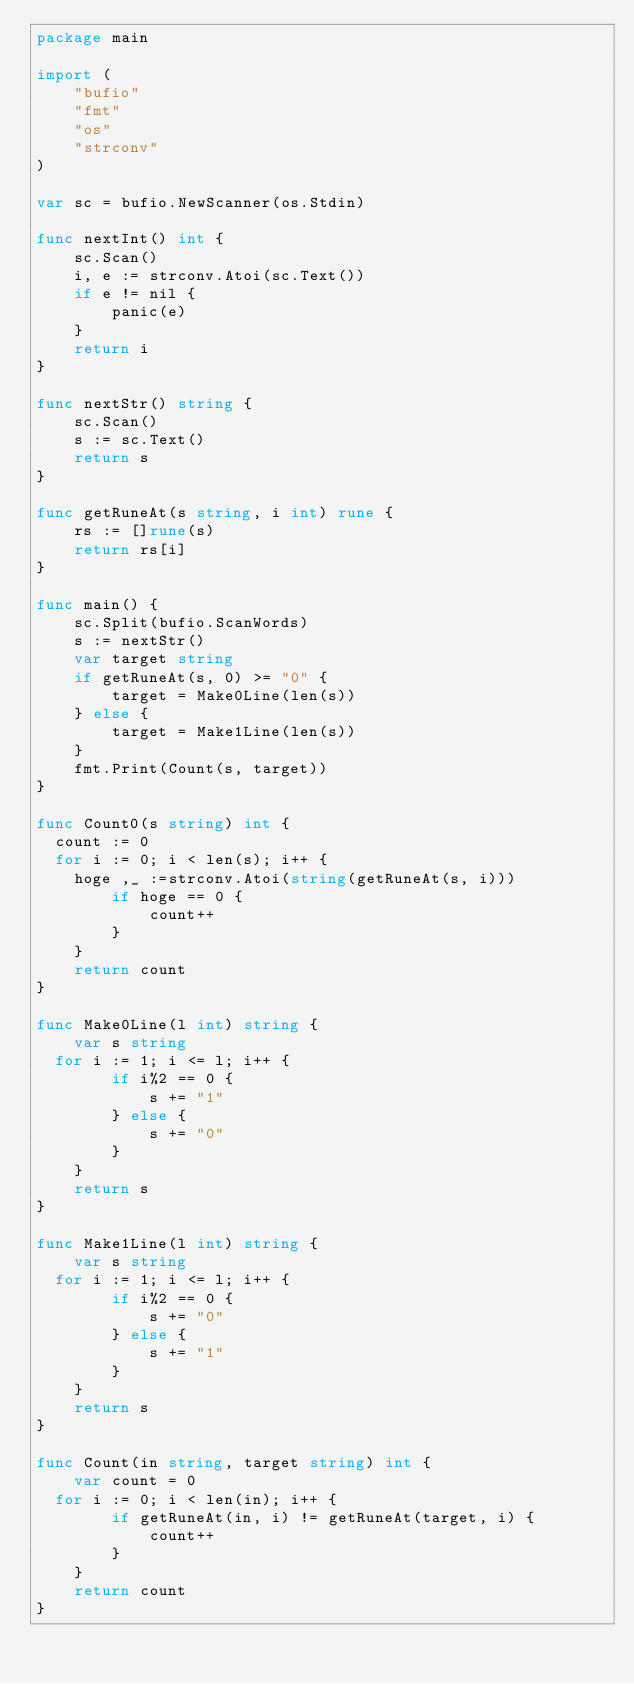Convert code to text. <code><loc_0><loc_0><loc_500><loc_500><_Go_>package main

import (
	"bufio"
	"fmt"
	"os"
	"strconv"
)

var sc = bufio.NewScanner(os.Stdin)

func nextInt() int {
	sc.Scan()
	i, e := strconv.Atoi(sc.Text())
	if e != nil {
		panic(e)
	}
	return i
}

func nextStr() string {
	sc.Scan()
	s := sc.Text()
	return s
}

func getRuneAt(s string, i int) rune {
	rs := []rune(s)
	return rs[i]
}

func main() {
	sc.Split(bufio.ScanWords)
	s := nextStr()
	var target string
	if getRuneAt(s, 0) >= "0" {
		target = Make0Line(len(s))
	} else {
		target = Make1Line(len(s))
	}
	fmt.Print(Count(s, target))
}

func Count0(s string) int {
  count := 0
  for i := 0; i < len(s); i++ {
    hoge ,_ :=strconv.Atoi(string(getRuneAt(s, i)))
		if hoge == 0 {
			count++
		}
	}
	return count
}

func Make0Line(l int) string {
	var s string
  for i := 1; i <= l; i++ {
		if i%2 == 0 {
			s += "1"
		} else {
			s += "0"
		}
	}
	return s
}

func Make1Line(l int) string {
	var s string
  for i := 1; i <= l; i++ {
		if i%2 == 0 {
			s += "0"
		} else {
			s += "1"
		}
	}
	return s
}

func Count(in string, target string) int {
	var count = 0
  for i := 0; i < len(in); i++ {
		if getRuneAt(in, i) != getRuneAt(target, i) {
			count++
		}
	}
	return count
}</code> 